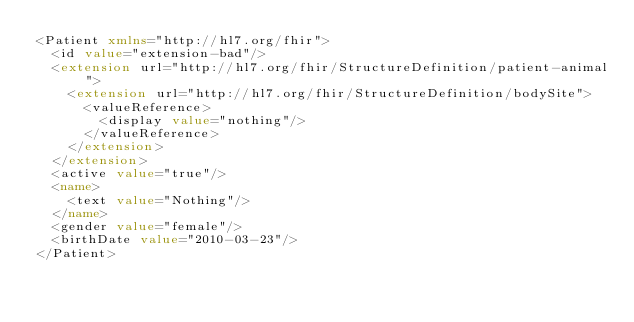Convert code to text. <code><loc_0><loc_0><loc_500><loc_500><_XML_><Patient xmlns="http://hl7.org/fhir">
  <id value="extension-bad"/>
  <extension url="http://hl7.org/fhir/StructureDefinition/patient-animal">
    <extension url="http://hl7.org/fhir/StructureDefinition/bodySite">
      <valueReference>
        <display value="nothing"/>
      </valueReference>
    </extension>
  </extension>
  <active value="true"/>
  <name>
    <text value="Nothing"/>
  </name>
  <gender value="female"/>
  <birthDate value="2010-03-23"/>
</Patient></code> 